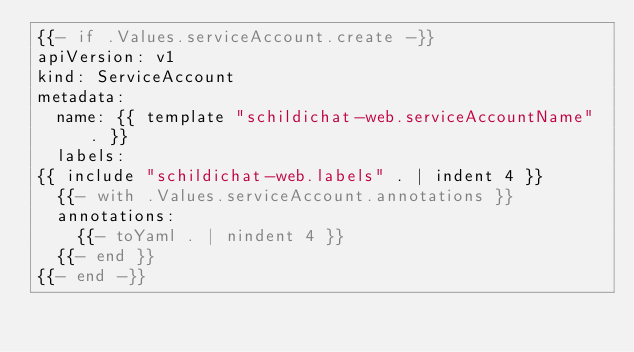Convert code to text. <code><loc_0><loc_0><loc_500><loc_500><_YAML_>{{- if .Values.serviceAccount.create -}}
apiVersion: v1
kind: ServiceAccount
metadata:
  name: {{ template "schildichat-web.serviceAccountName" . }}
  labels:
{{ include "schildichat-web.labels" . | indent 4 }}
  {{- with .Values.serviceAccount.annotations }}
  annotations:
    {{- toYaml . | nindent 4 }}
  {{- end }}
{{- end -}}
</code> 